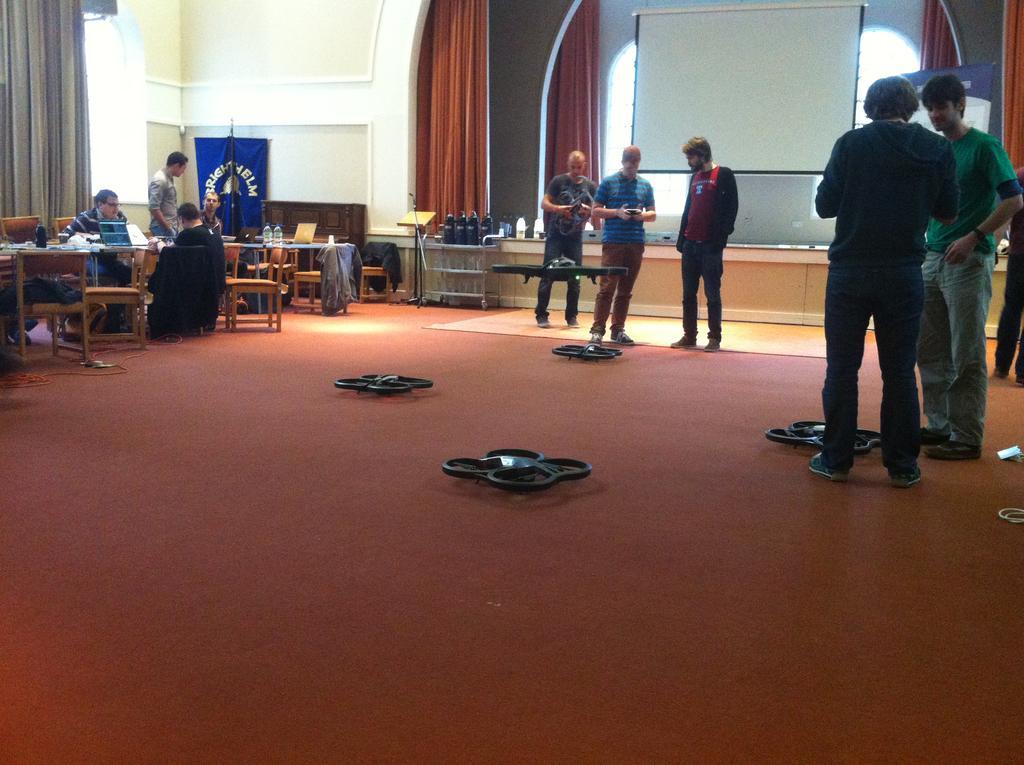Describe this image in one or two sentences. In the image in the center we can see three persons were standing. On the right we can see two persons were standing. On the left we can see four persons,three persons were sitting and one person standing. In the center we can see plane and remote. And back we can see wall,board and curtains and few objects around them. 